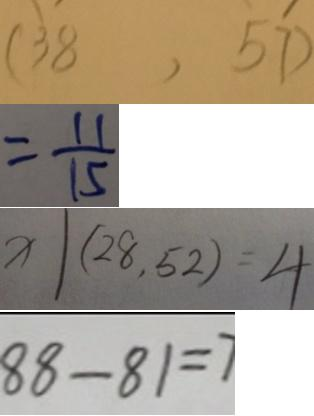<formula> <loc_0><loc_0><loc_500><loc_500>( 3 8 , 5 7 ) 
 = \frac { 1 1 } { 1 5 } 
 x \vert ( 2 8 , 5 2 ) = 4 
 8 8 - 8 1 = 7</formula> 